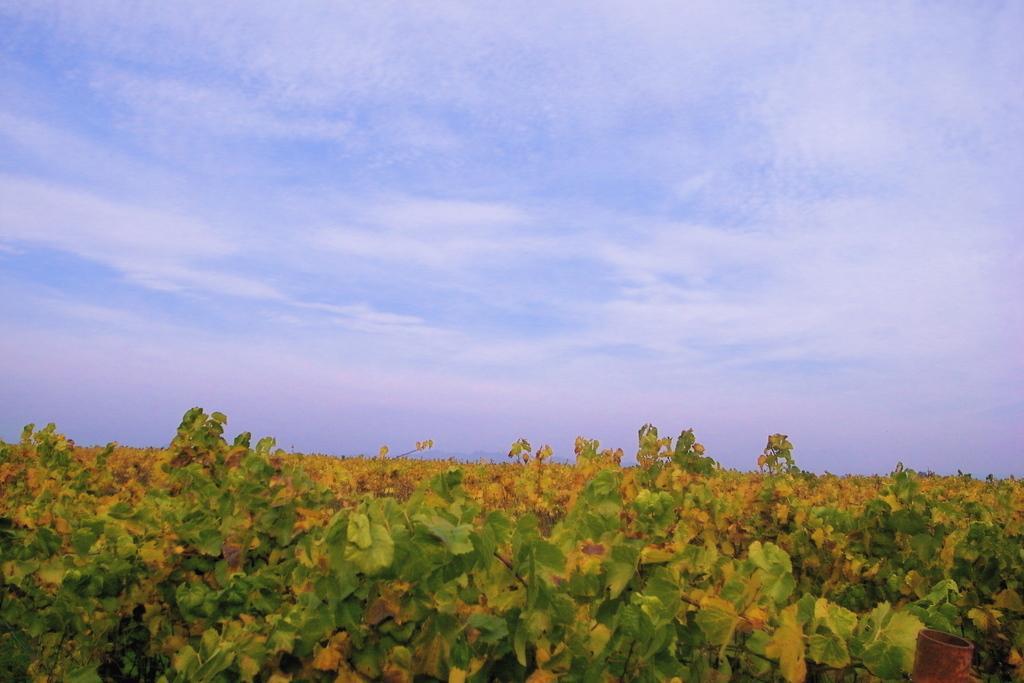In one or two sentences, can you explain what this image depicts? At the bottom of the picture, we see the plants or the trees. These trees are in green and yellow color. In the right bottom, we see a rod or a pole in brown color. At the top, we see the sky and the clouds. 